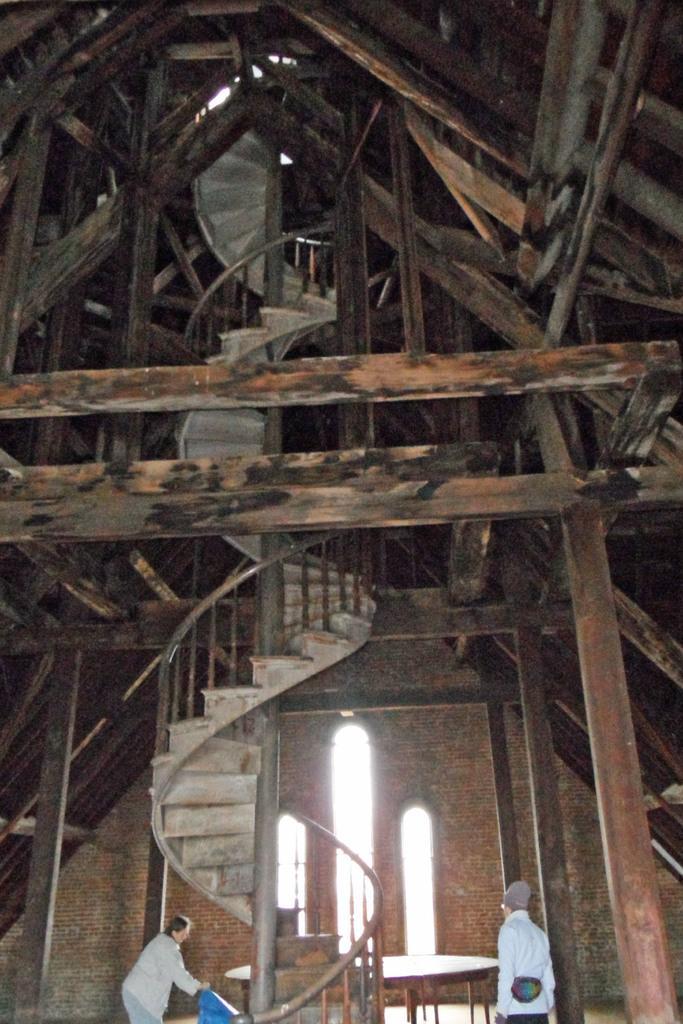Describe this image in one or two sentences. In this image I see the view of a building and there are stairs over here and there are 2 persons. 